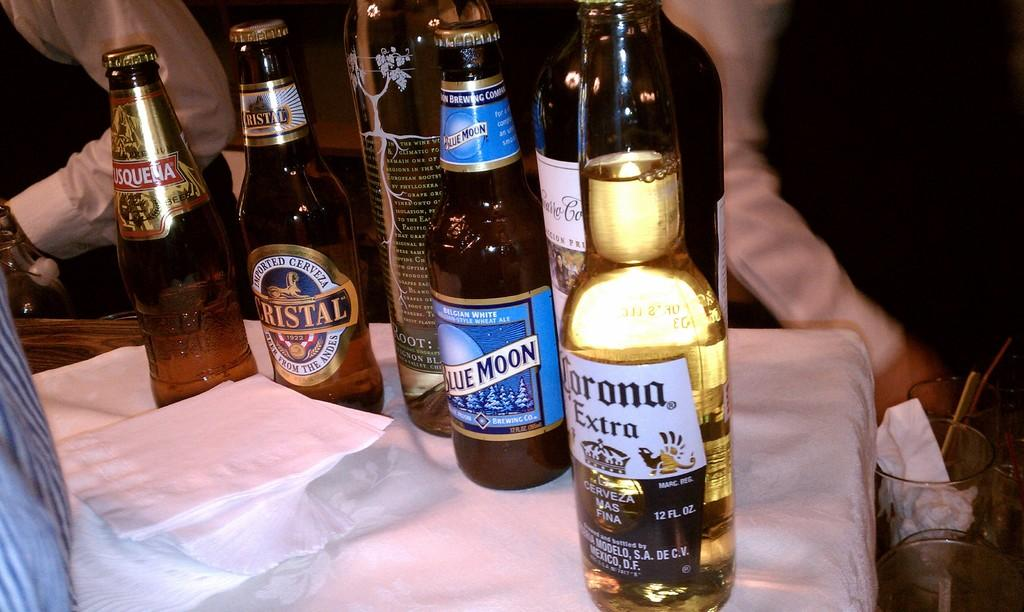Provide a one-sentence caption for the provided image. Bottle of Corona Extra next to a bottle of Blue Moon. 